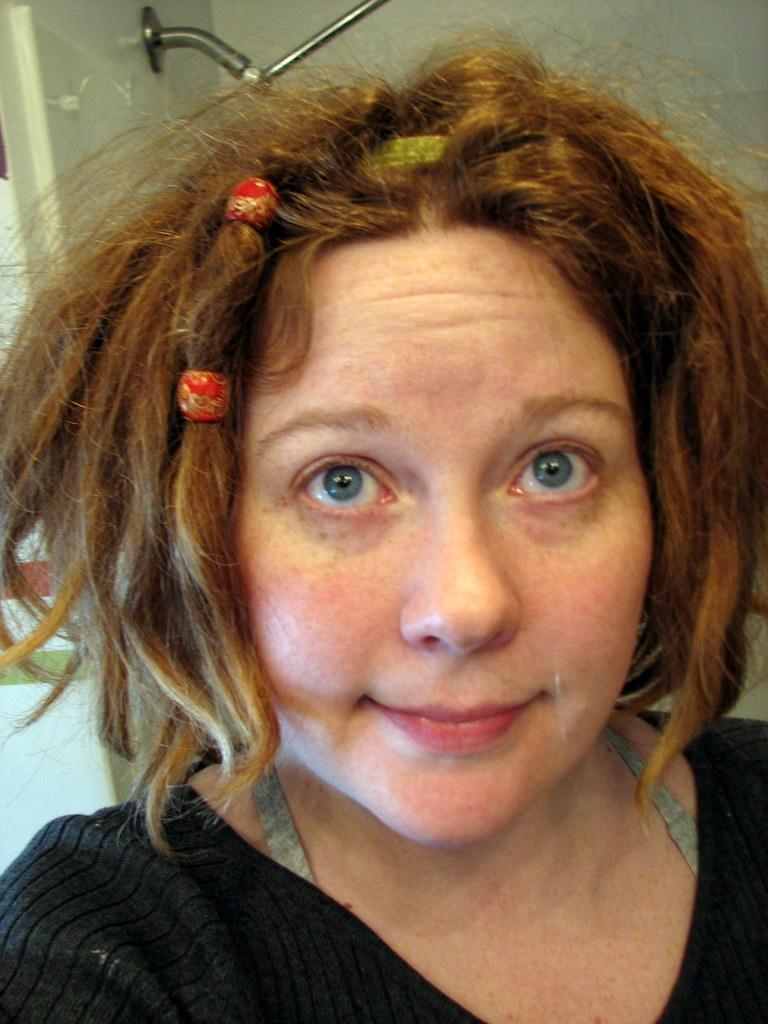Who is the main subject in the image? There is a lady in the center of the image. What is the setting or context of the image? It appears to be a shower scene. Can you describe any other objects or elements in the image? There are other objects in the background of the image. What type of beef is being served on the tray in the image? There is no tray or beef present in the image. 